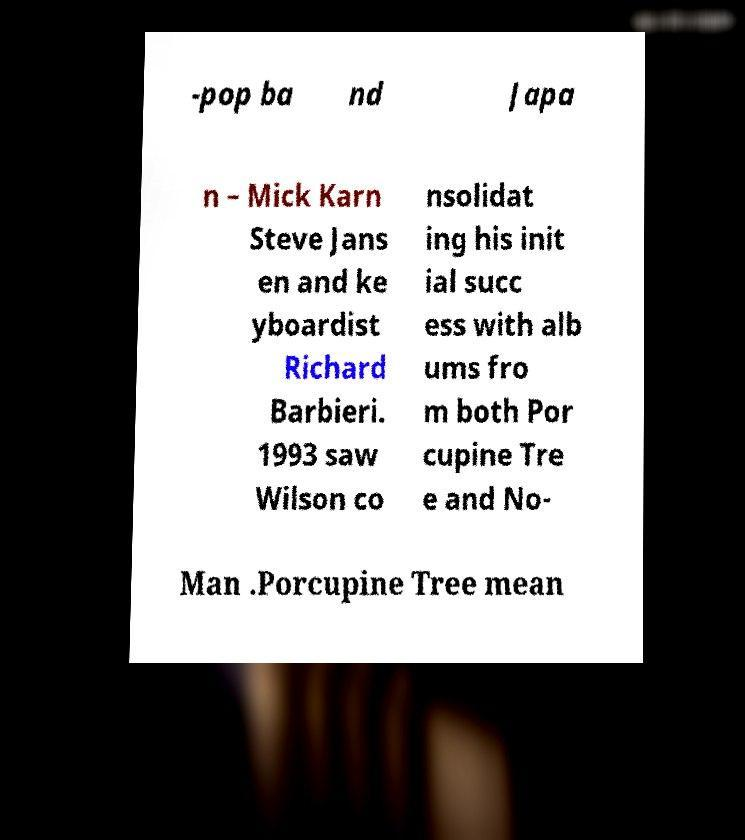Could you assist in decoding the text presented in this image and type it out clearly? -pop ba nd Japa n – Mick Karn Steve Jans en and ke yboardist Richard Barbieri. 1993 saw Wilson co nsolidat ing his init ial succ ess with alb ums fro m both Por cupine Tre e and No- Man .Porcupine Tree mean 